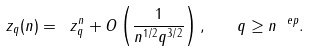Convert formula to latex. <formula><loc_0><loc_0><loc_500><loc_500>\ z _ { q } ( n ) = \ z _ { q } ^ { n } + O \left ( \frac { 1 } { n ^ { 1 / 2 } q ^ { 3 / 2 } } \right ) , \quad q \geq n ^ { \ e p } .</formula> 